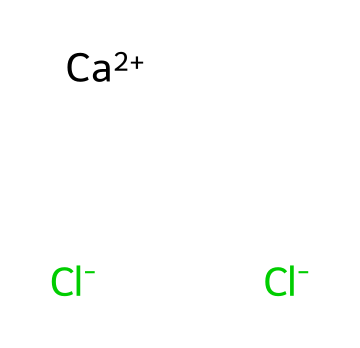What is the chemical name of this compound? The SMILES representation indicates the presence of calcium (Ca) and chlorine (Cl) atoms. Combining this information leads to the common name for the compound, which is calcium chloride.
Answer: calcium chloride How many chlorine atoms are present in this chemical? By analyzing the SMILES notation, there are two chlorine atoms represented by [Cl-] being present. This is confirmed as the notation shows two instances of chlorine.
Answer: two What is the oxidation state of calcium in this compound? The notation [Ca+2] indicates that calcium has a +2 charge, which signifies its oxidation state in calcium chloride. This reflects its tendency to lose two electrons.
Answer: +2 What type of chemical structure does calcium chloride represent? Calcium chloride is shown as an ionic compound due to the presence of ions ([Ca+2] and [Cl-]). This implies it consists of positively and negatively charged particles.
Answer: ionic What is the total number of atoms in this chemical structure? Analyzing the notation, we see one calcium atom and two chlorine atoms, leading to a sum of three atoms in total in the structure.
Answer: three Which type of electrolyte is calcium chloride? The SMILES shows that calcium chloride dissociates into ions when dissolved, indicating that it is a strong electrolyte, because it completely ionizes in aqueous solutions.
Answer: strong 